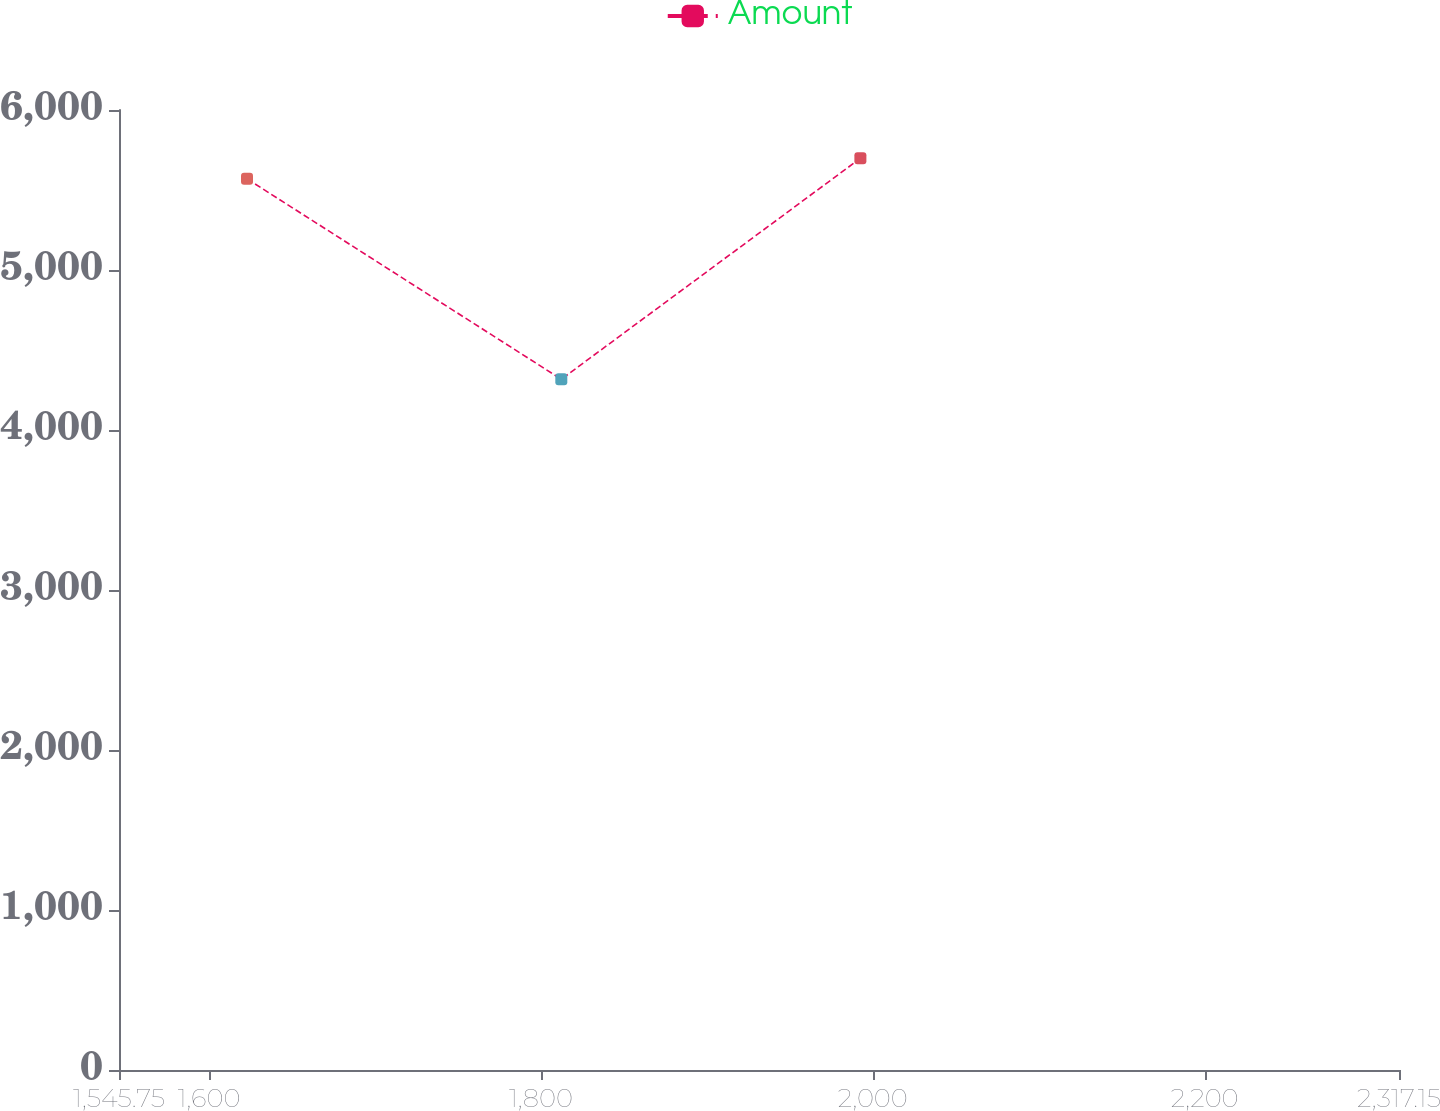<chart> <loc_0><loc_0><loc_500><loc_500><line_chart><ecel><fcel>Amount<nl><fcel>1622.89<fcel>5569.83<nl><fcel>1812.31<fcel>4317.1<nl><fcel>1992.55<fcel>5698<nl><fcel>2321.73<fcel>4452.23<nl><fcel>2394.29<fcel>4580.4<nl></chart> 